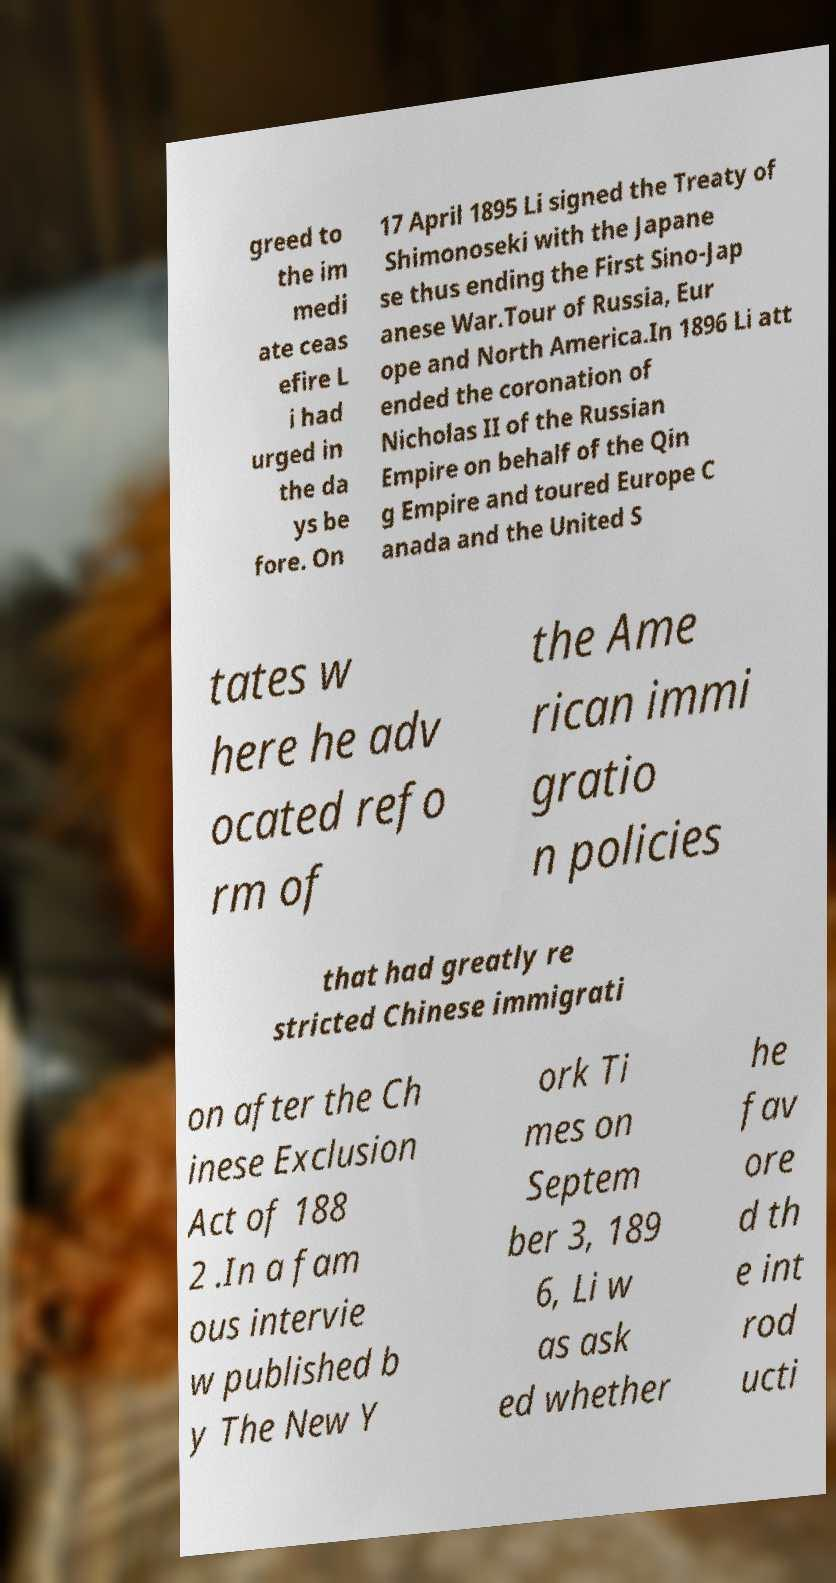Can you accurately transcribe the text from the provided image for me? greed to the im medi ate ceas efire L i had urged in the da ys be fore. On 17 April 1895 Li signed the Treaty of Shimonoseki with the Japane se thus ending the First Sino-Jap anese War.Tour of Russia, Eur ope and North America.In 1896 Li att ended the coronation of Nicholas II of the Russian Empire on behalf of the Qin g Empire and toured Europe C anada and the United S tates w here he adv ocated refo rm of the Ame rican immi gratio n policies that had greatly re stricted Chinese immigrati on after the Ch inese Exclusion Act of 188 2 .In a fam ous intervie w published b y The New Y ork Ti mes on Septem ber 3, 189 6, Li w as ask ed whether he fav ore d th e int rod ucti 